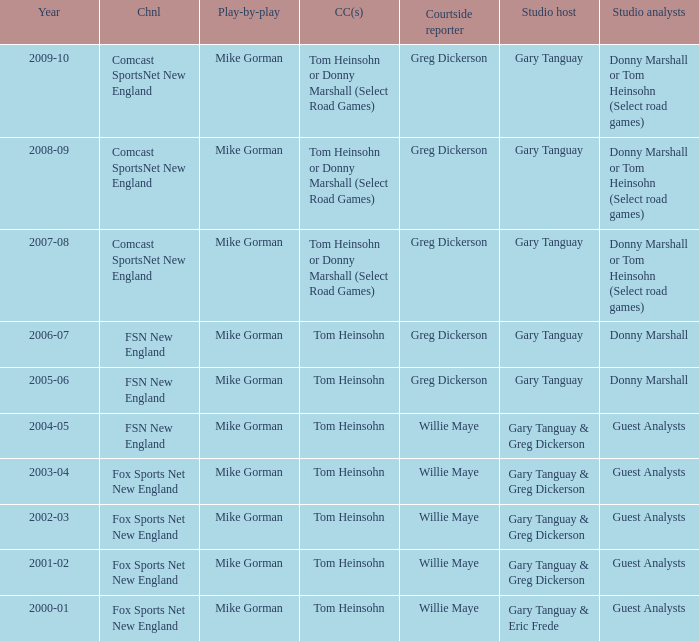Which Courtside reporter has a Channel of fsn new england in 2006-07? Greg Dickerson. 